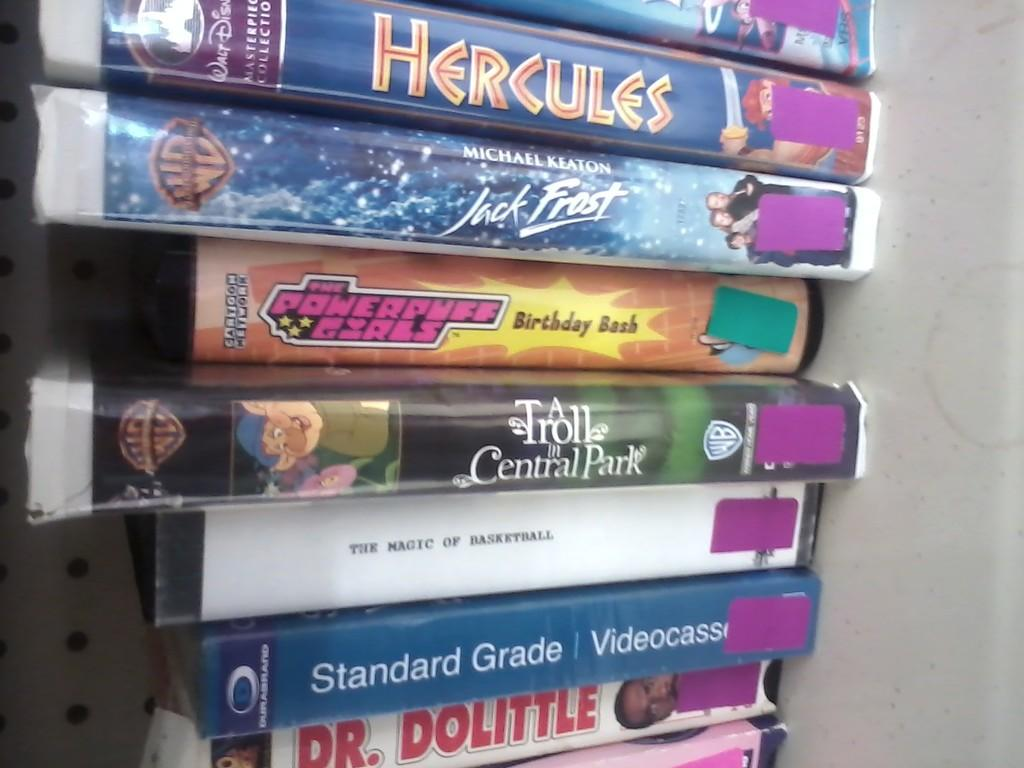<image>
Present a compact description of the photo's key features. A stack of cases shows the names of different movies starting with Hercules on top. 